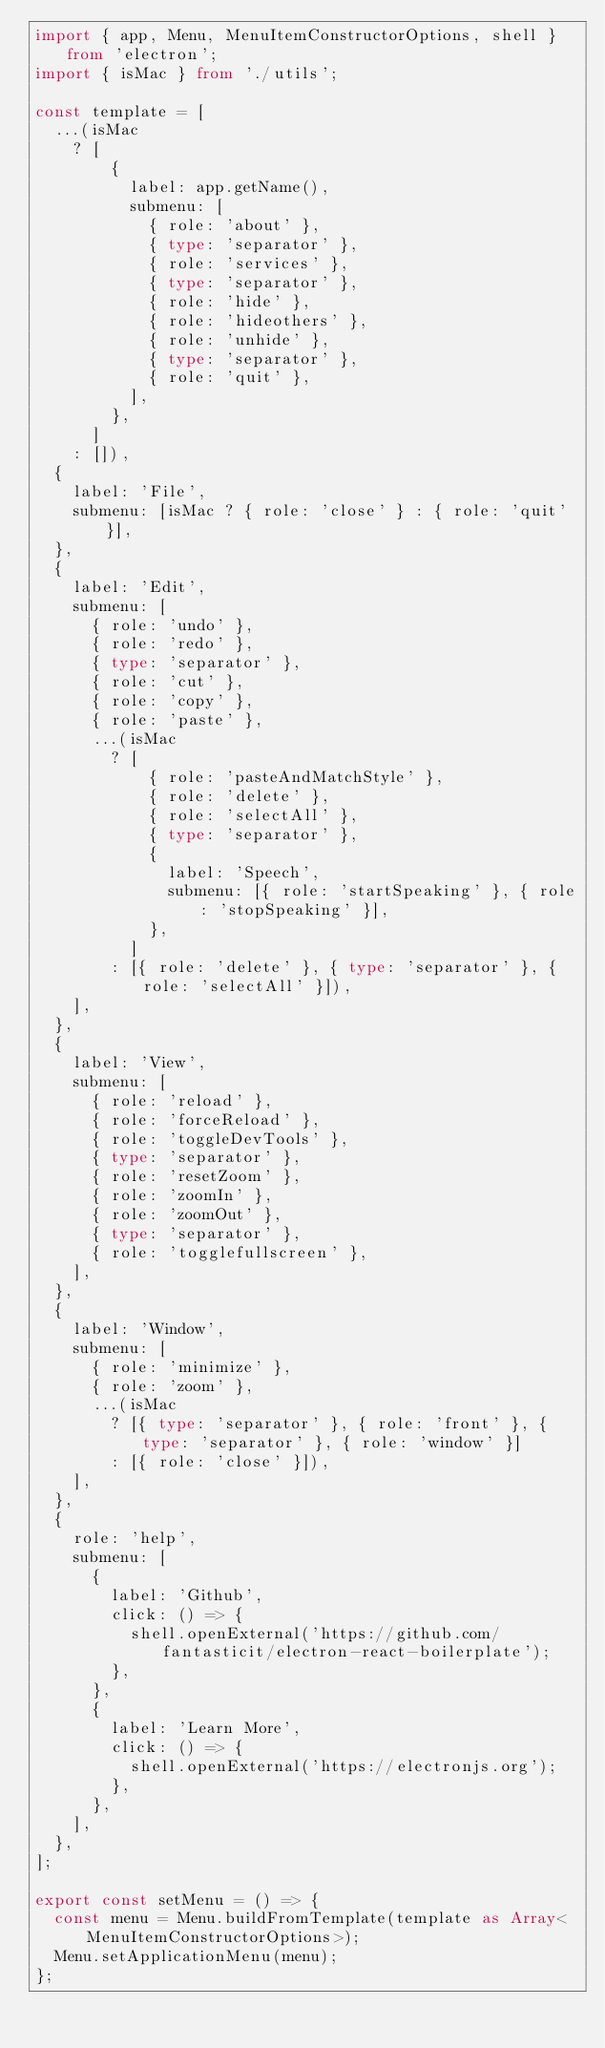Convert code to text. <code><loc_0><loc_0><loc_500><loc_500><_TypeScript_>import { app, Menu, MenuItemConstructorOptions, shell } from 'electron';
import { isMac } from './utils';

const template = [
  ...(isMac
    ? [
        {
          label: app.getName(),
          submenu: [
            { role: 'about' },
            { type: 'separator' },
            { role: 'services' },
            { type: 'separator' },
            { role: 'hide' },
            { role: 'hideothers' },
            { role: 'unhide' },
            { type: 'separator' },
            { role: 'quit' },
          ],
        },
      ]
    : []),
  {
    label: 'File',
    submenu: [isMac ? { role: 'close' } : { role: 'quit' }],
  },
  {
    label: 'Edit',
    submenu: [
      { role: 'undo' },
      { role: 'redo' },
      { type: 'separator' },
      { role: 'cut' },
      { role: 'copy' },
      { role: 'paste' },
      ...(isMac
        ? [
            { role: 'pasteAndMatchStyle' },
            { role: 'delete' },
            { role: 'selectAll' },
            { type: 'separator' },
            {
              label: 'Speech',
              submenu: [{ role: 'startSpeaking' }, { role: 'stopSpeaking' }],
            },
          ]
        : [{ role: 'delete' }, { type: 'separator' }, { role: 'selectAll' }]),
    ],
  },
  {
    label: 'View',
    submenu: [
      { role: 'reload' },
      { role: 'forceReload' },
      { role: 'toggleDevTools' },
      { type: 'separator' },
      { role: 'resetZoom' },
      { role: 'zoomIn' },
      { role: 'zoomOut' },
      { type: 'separator' },
      { role: 'togglefullscreen' },
    ],
  },
  {
    label: 'Window',
    submenu: [
      { role: 'minimize' },
      { role: 'zoom' },
      ...(isMac
        ? [{ type: 'separator' }, { role: 'front' }, { type: 'separator' }, { role: 'window' }]
        : [{ role: 'close' }]),
    ],
  },
  {
    role: 'help',
    submenu: [
      {
        label: 'Github',
        click: () => {
          shell.openExternal('https://github.com/fantasticit/electron-react-boilerplate');
        },
      },
      {
        label: 'Learn More',
        click: () => {
          shell.openExternal('https://electronjs.org');
        },
      },
    ],
  },
];

export const setMenu = () => {
  const menu = Menu.buildFromTemplate(template as Array<MenuItemConstructorOptions>);
  Menu.setApplicationMenu(menu);
};
</code> 